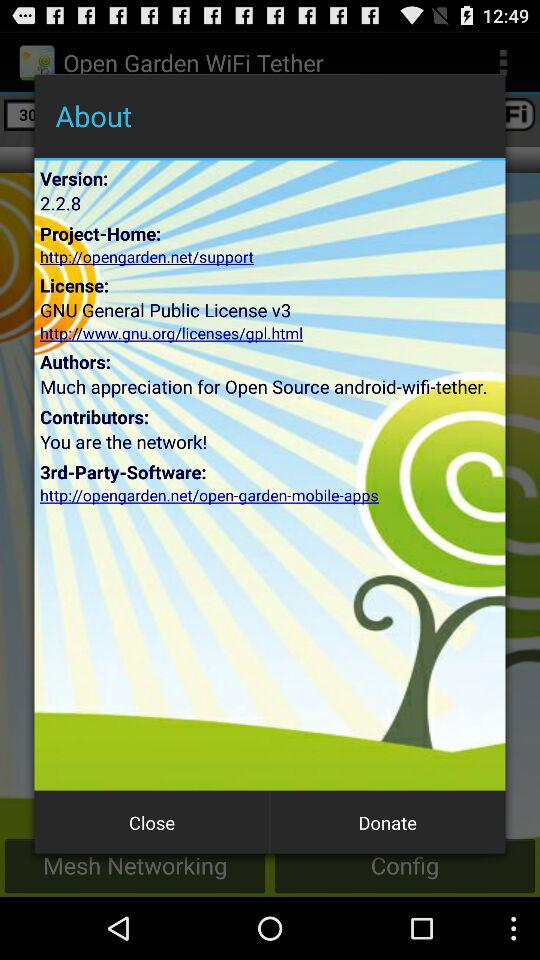What version of the application is this? The version is 2.2.8. 